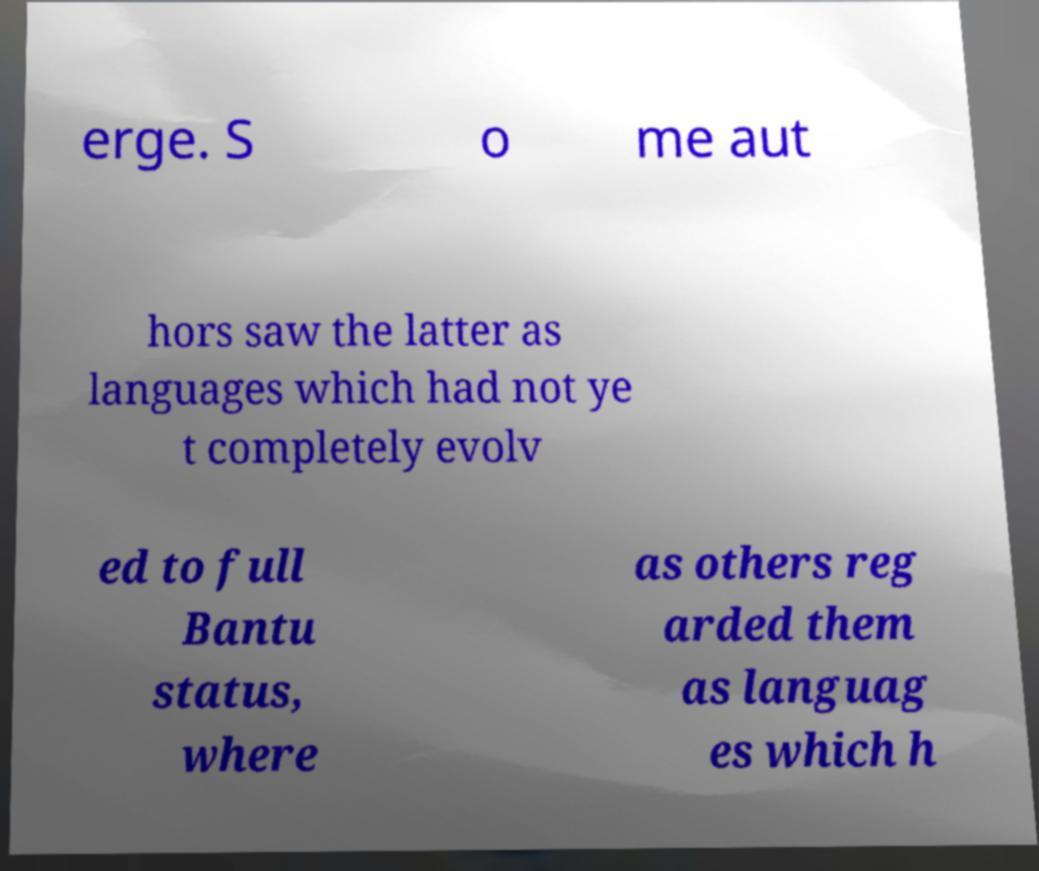Can you accurately transcribe the text from the provided image for me? erge. S o me aut hors saw the latter as languages which had not ye t completely evolv ed to full Bantu status, where as others reg arded them as languag es which h 